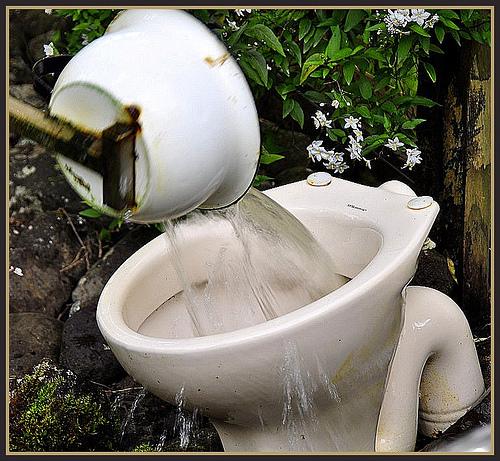Is this toilet indoors?
Be succinct. No. What is growing behind the toilet?
Concise answer only. Flowers. What is being put in the toilet?
Quick response, please. Water. 